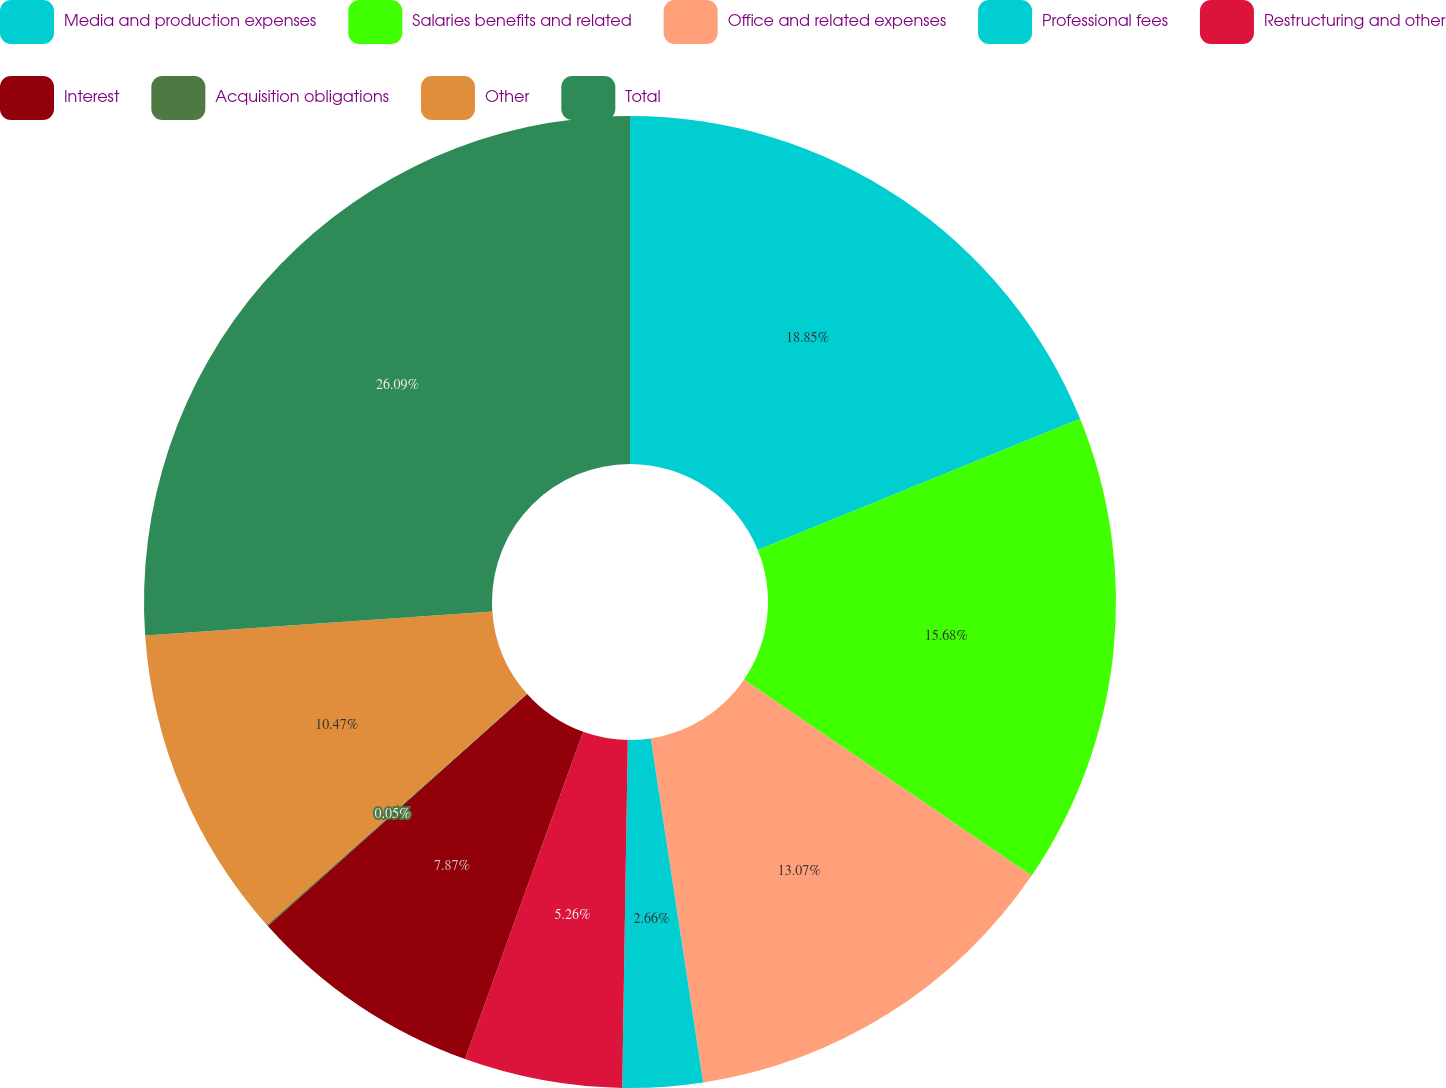Convert chart to OTSL. <chart><loc_0><loc_0><loc_500><loc_500><pie_chart><fcel>Media and production expenses<fcel>Salaries benefits and related<fcel>Office and related expenses<fcel>Professional fees<fcel>Restructuring and other<fcel>Interest<fcel>Acquisition obligations<fcel>Other<fcel>Total<nl><fcel>18.85%<fcel>15.68%<fcel>13.07%<fcel>2.66%<fcel>5.26%<fcel>7.87%<fcel>0.05%<fcel>10.47%<fcel>26.1%<nl></chart> 